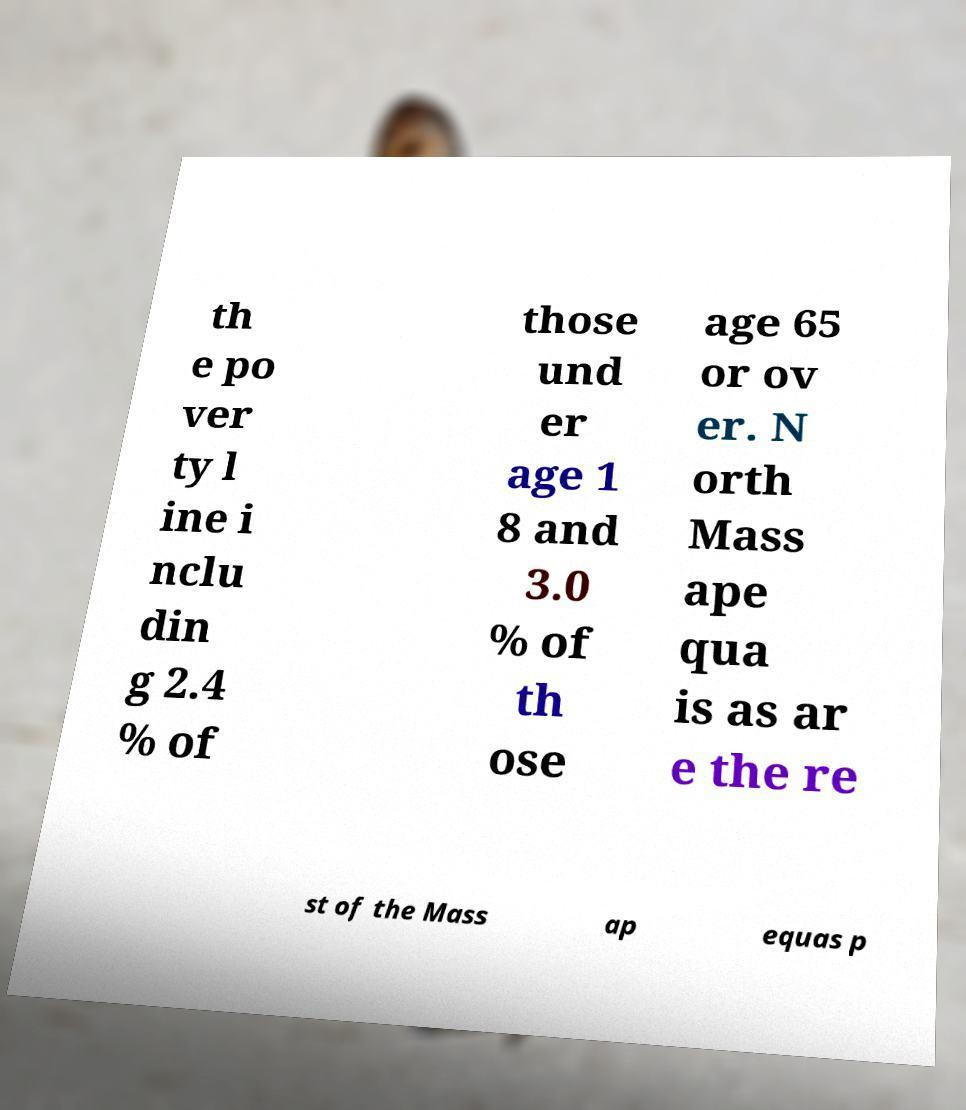There's text embedded in this image that I need extracted. Can you transcribe it verbatim? th e po ver ty l ine i nclu din g 2.4 % of those und er age 1 8 and 3.0 % of th ose age 65 or ov er. N orth Mass ape qua is as ar e the re st of the Mass ap equas p 